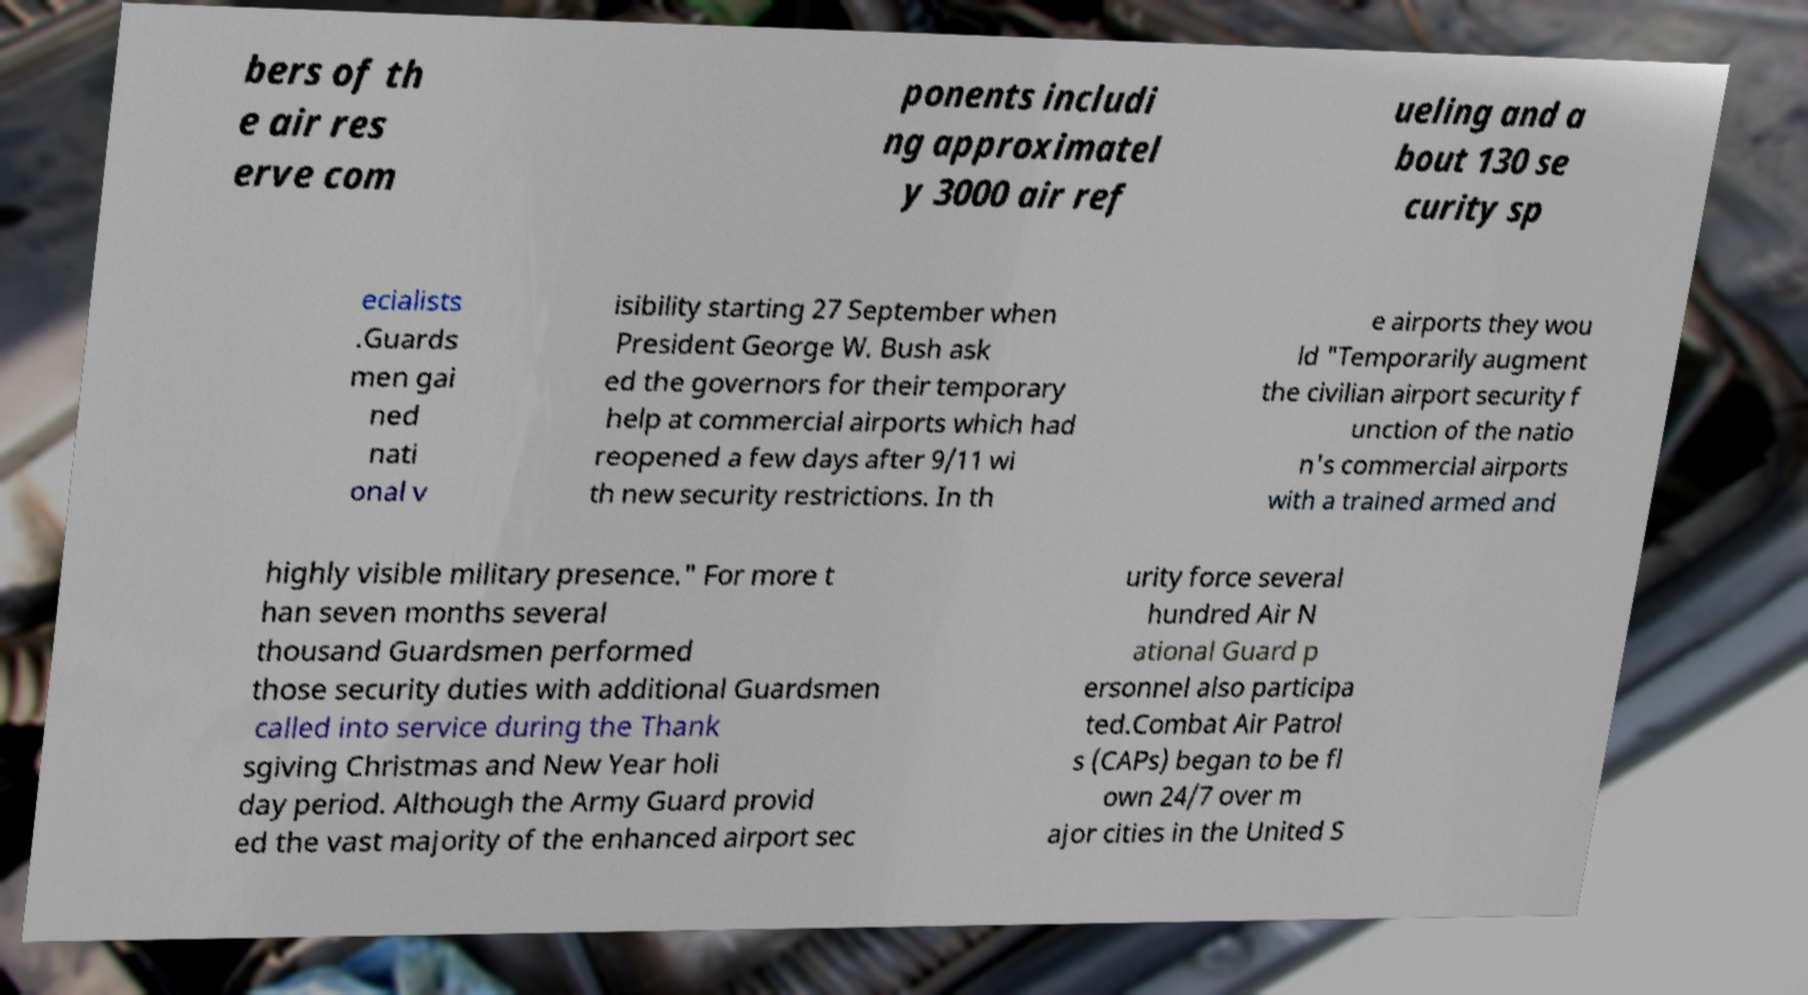For documentation purposes, I need the text within this image transcribed. Could you provide that? bers of th e air res erve com ponents includi ng approximatel y 3000 air ref ueling and a bout 130 se curity sp ecialists .Guards men gai ned nati onal v isibility starting 27 September when President George W. Bush ask ed the governors for their temporary help at commercial airports which had reopened a few days after 9/11 wi th new security restrictions. In th e airports they wou ld "Temporarily augment the civilian airport security f unction of the natio n's commercial airports with a trained armed and highly visible military presence." For more t han seven months several thousand Guardsmen performed those security duties with additional Guardsmen called into service during the Thank sgiving Christmas and New Year holi day period. Although the Army Guard provid ed the vast majority of the enhanced airport sec urity force several hundred Air N ational Guard p ersonnel also participa ted.Combat Air Patrol s (CAPs) began to be fl own 24/7 over m ajor cities in the United S 